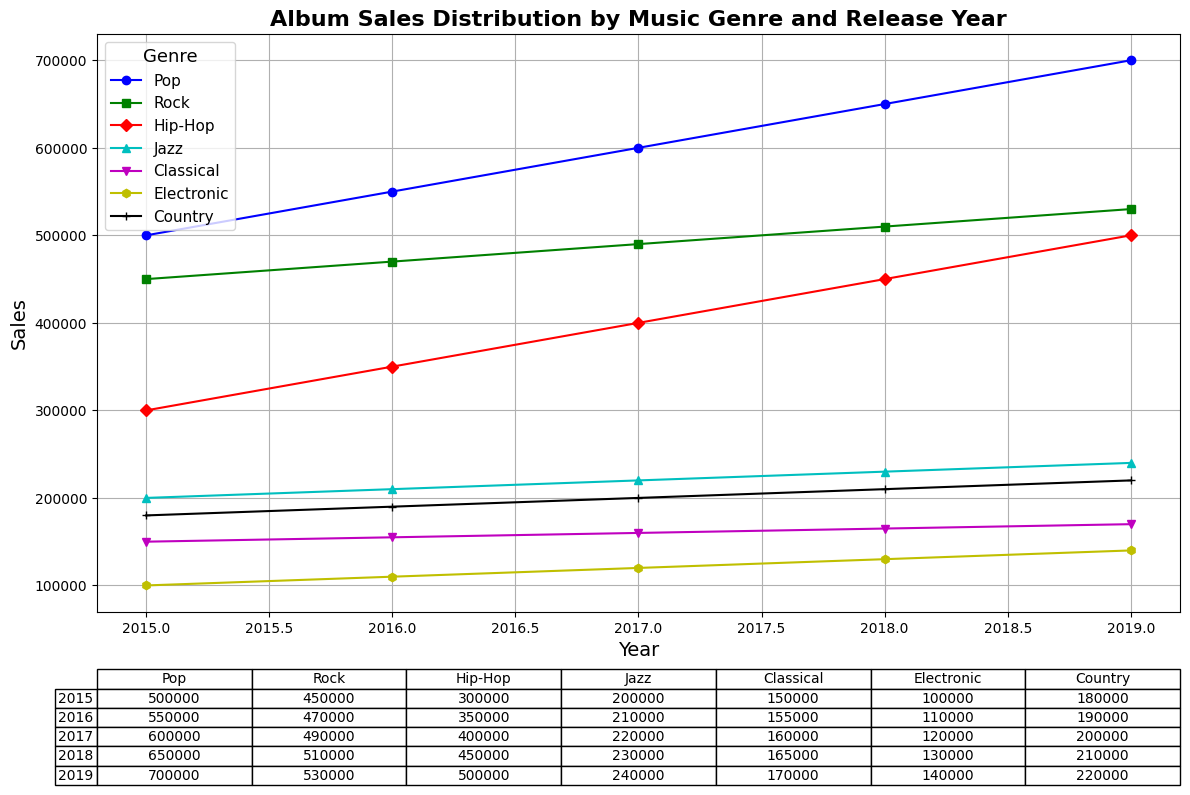What is the total sales of Pop albums from 2015 to 2019? To find the total sales of Pop albums from 2015 to 2019, sum the values for each year: 500000 + 550000 + 600000 + 650000 + 700000, which gives 3000000.
Answer: 3000000 Which genre had the highest sales in 2019? From the 2019 column, compare the sales values for each genre: Pop (700000), Rock (530000), Hip-Hop (500000), Jazz (240000), Classical (170000), Electronic (140000), and Country (220000). Pop has the highest sales.
Answer: Pop What is the percentage increase in Hip-Hop album sales from 2015 to 2019? The percentage increase is calculated as ((Sales in 2019 - Sales in 2015) / Sales in 2015) * 100. Plugging in the values: ((500000 - 300000) / 300000) * 100 = 66.67%.
Answer: 66.67% How much did Jazz album sales increase from 2017 to 2018? To find the increase in sales, subtract the 2017 sales from the 2018 sales: 230000 - 220000 = 10000.
Answer: 10000 Which year showed the highest sales for Classical albums? Check the sales values for Classical albums across all years: 2015 (150000), 2016 (155000), 2017 (160000), 2018 (165000), and 2019 (170000). 2019 has the highest sales.
Answer: 2019 Which genre had the smallest increase in sales from 2015 to 2019? Calculate the sales increase for each genre: 
Pop: 700000 - 500000 = 200000 
Rock: 530000 - 450000 = 80000 
Hip-Hop: 500000 - 300000 = 200000 
Jazz: 240000 - 200000 = 40000 
Classical: 170000 - 150000 = 20000 
Electronic: 140000 - 100000 = 40000 
Country: 220000 - 180000 = 40000. 
Classical has the smallest increase at 20000.
Answer: Classical What visual pattern can you infer regarding the sales trends of all genres from 2015 to 2019? Observing the chart, all genres show a generally increasing trend in sales from 2015 to 2019. This can be inferred from the upward direction of the lines for each genre.
Answer: Increasing trend Which genre had consistently lower sales compared to other genres each year from 2015 to 2019? Examine each year's data and identify which genre consistently has the lowest sales values: 
2015: Electronic (100000) 
2016: Electronic (110000) 
2017: Electronic (120000) 
2018: Electronic (130000) 
2019: Electronic (140000). 
Electronic is consistently lower.
Answer: Electronic 